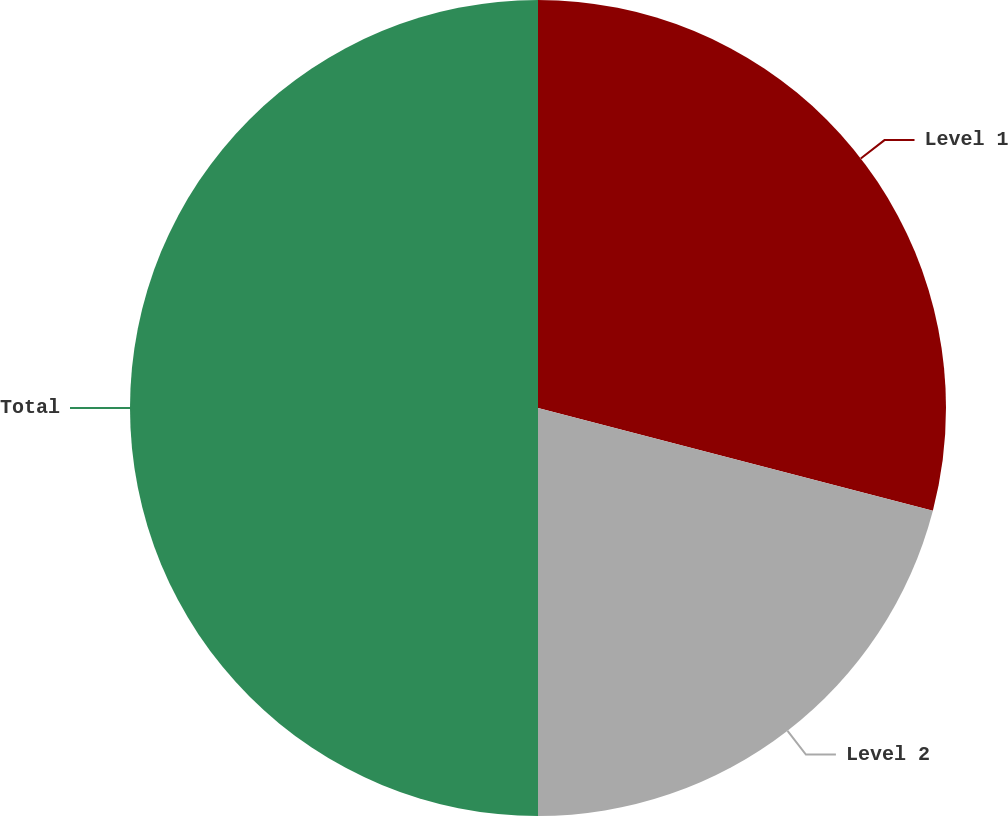Convert chart. <chart><loc_0><loc_0><loc_500><loc_500><pie_chart><fcel>Level 1<fcel>Level 2<fcel>Total<nl><fcel>29.05%<fcel>20.95%<fcel>50.0%<nl></chart> 